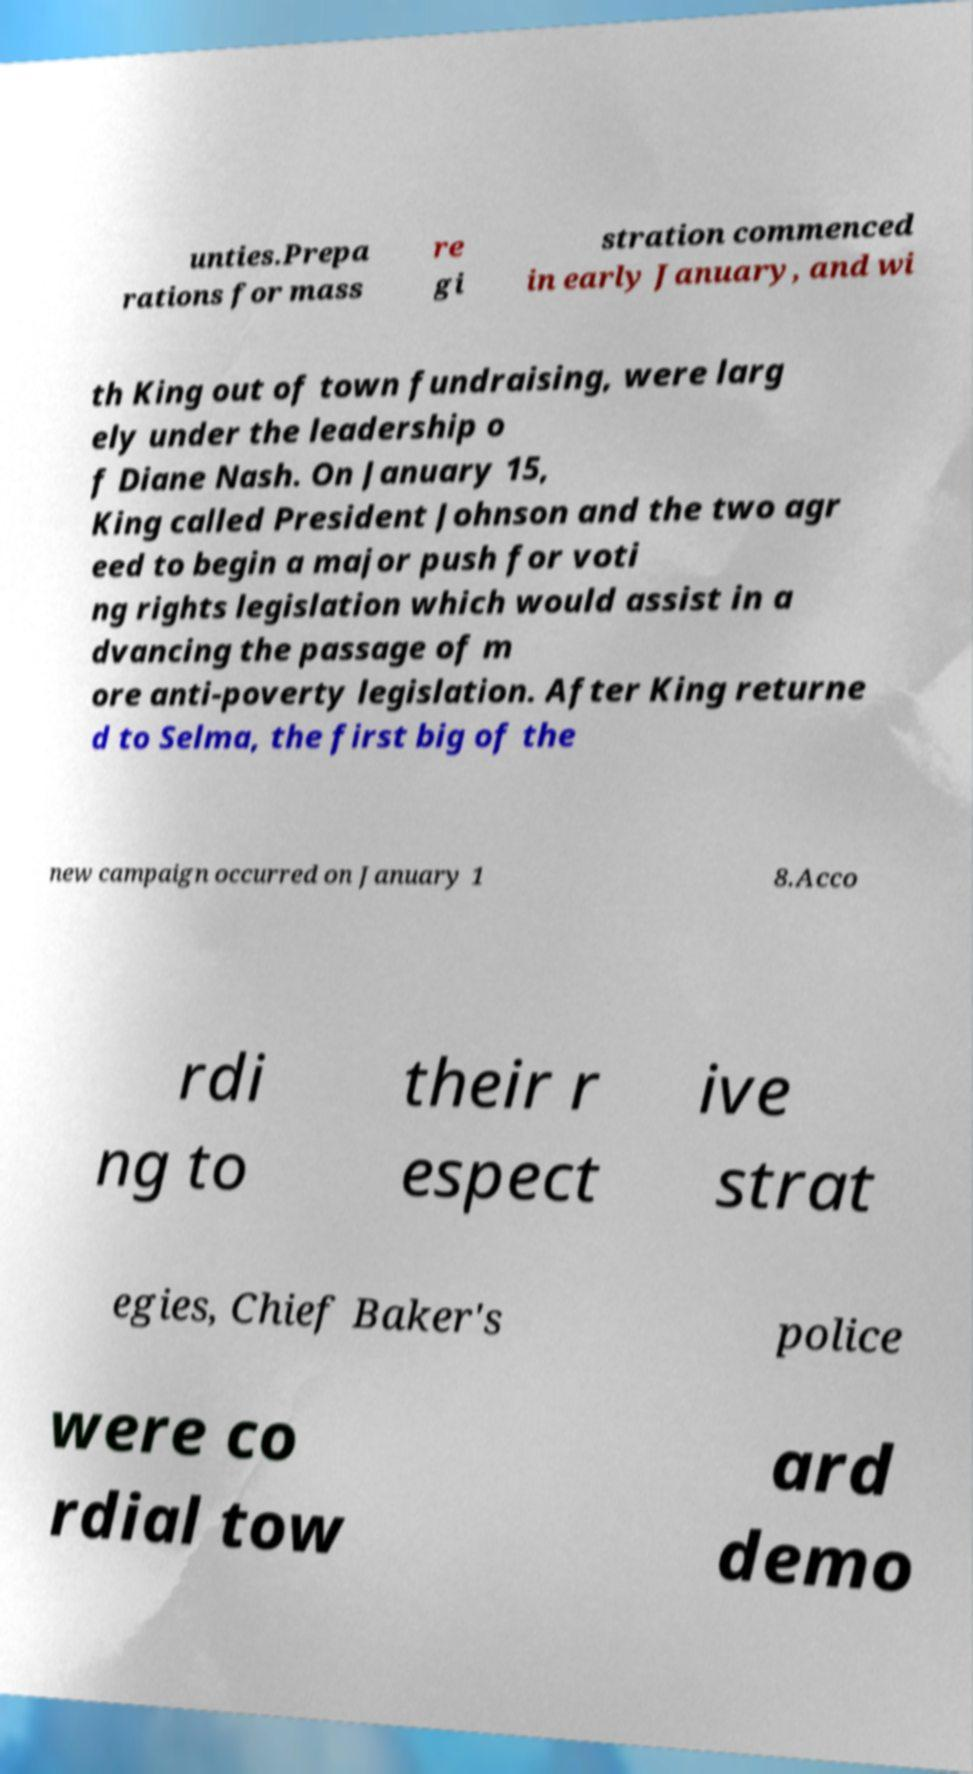For documentation purposes, I need the text within this image transcribed. Could you provide that? unties.Prepa rations for mass re gi stration commenced in early January, and wi th King out of town fundraising, were larg ely under the leadership o f Diane Nash. On January 15, King called President Johnson and the two agr eed to begin a major push for voti ng rights legislation which would assist in a dvancing the passage of m ore anti-poverty legislation. After King returne d to Selma, the first big of the new campaign occurred on January 1 8.Acco rdi ng to their r espect ive strat egies, Chief Baker's police were co rdial tow ard demo 